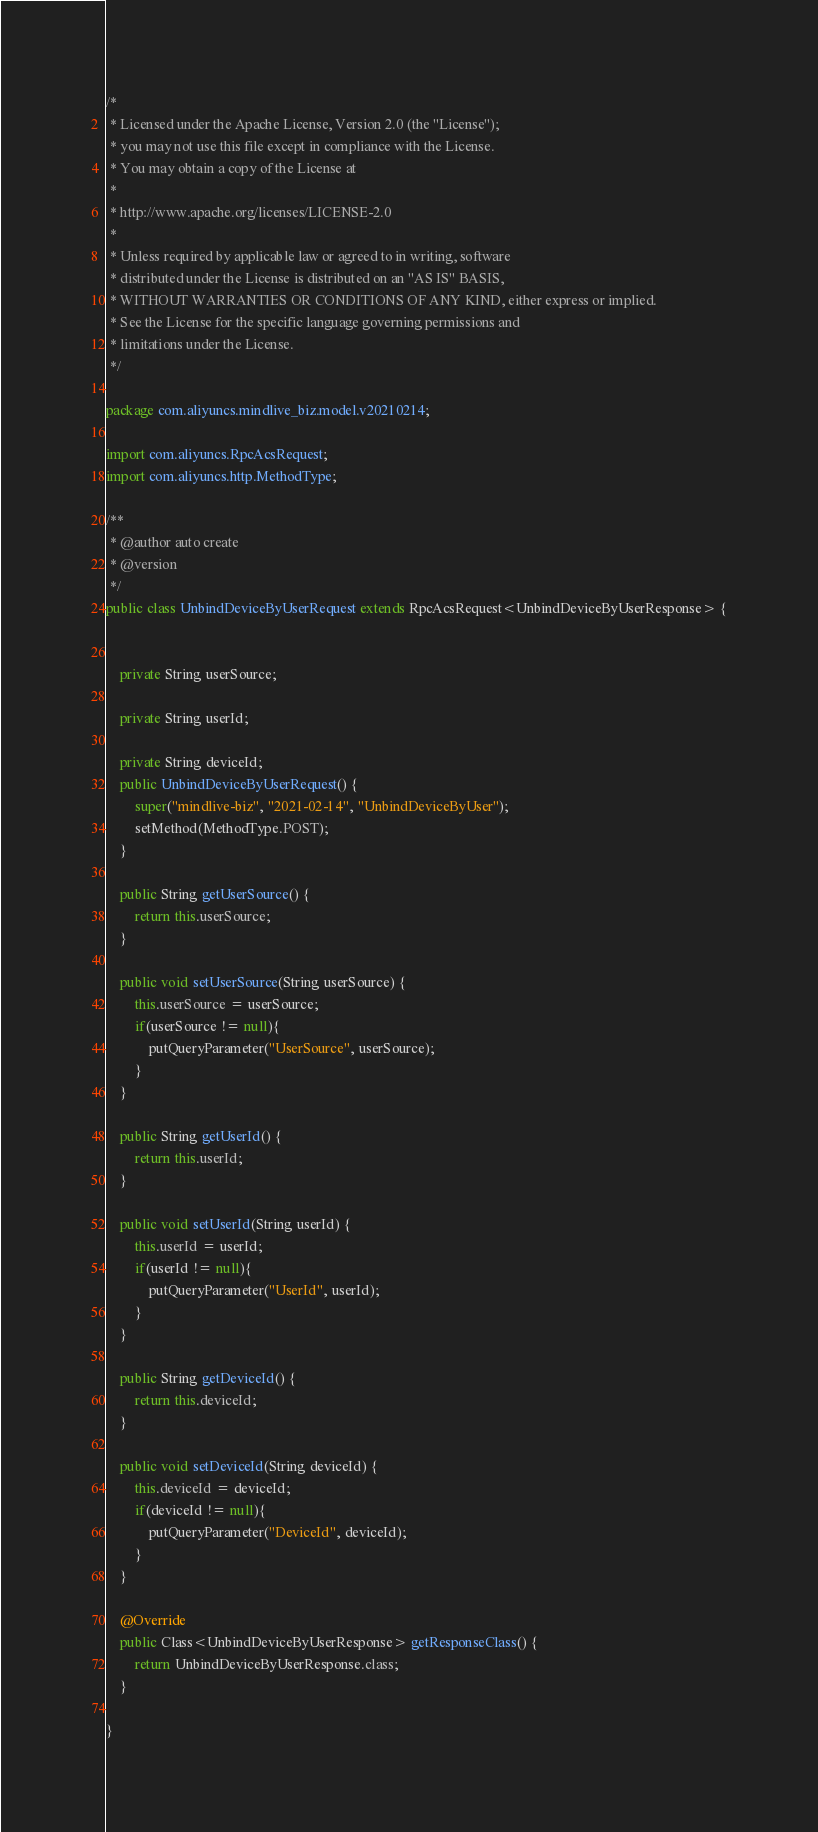<code> <loc_0><loc_0><loc_500><loc_500><_Java_>/*
 * Licensed under the Apache License, Version 2.0 (the "License");
 * you may not use this file except in compliance with the License.
 * You may obtain a copy of the License at
 *
 * http://www.apache.org/licenses/LICENSE-2.0
 *
 * Unless required by applicable law or agreed to in writing, software
 * distributed under the License is distributed on an "AS IS" BASIS,
 * WITHOUT WARRANTIES OR CONDITIONS OF ANY KIND, either express or implied.
 * See the License for the specific language governing permissions and
 * limitations under the License.
 */

package com.aliyuncs.mindlive_biz.model.v20210214;

import com.aliyuncs.RpcAcsRequest;
import com.aliyuncs.http.MethodType;

/**
 * @author auto create
 * @version 
 */
public class UnbindDeviceByUserRequest extends RpcAcsRequest<UnbindDeviceByUserResponse> {
	   

	private String userSource;

	private String userId;

	private String deviceId;
	public UnbindDeviceByUserRequest() {
		super("mindlive-biz", "2021-02-14", "UnbindDeviceByUser");
		setMethod(MethodType.POST);
	}

	public String getUserSource() {
		return this.userSource;
	}

	public void setUserSource(String userSource) {
		this.userSource = userSource;
		if(userSource != null){
			putQueryParameter("UserSource", userSource);
		}
	}

	public String getUserId() {
		return this.userId;
	}

	public void setUserId(String userId) {
		this.userId = userId;
		if(userId != null){
			putQueryParameter("UserId", userId);
		}
	}

	public String getDeviceId() {
		return this.deviceId;
	}

	public void setDeviceId(String deviceId) {
		this.deviceId = deviceId;
		if(deviceId != null){
			putQueryParameter("DeviceId", deviceId);
		}
	}

	@Override
	public Class<UnbindDeviceByUserResponse> getResponseClass() {
		return UnbindDeviceByUserResponse.class;
	}

}
</code> 